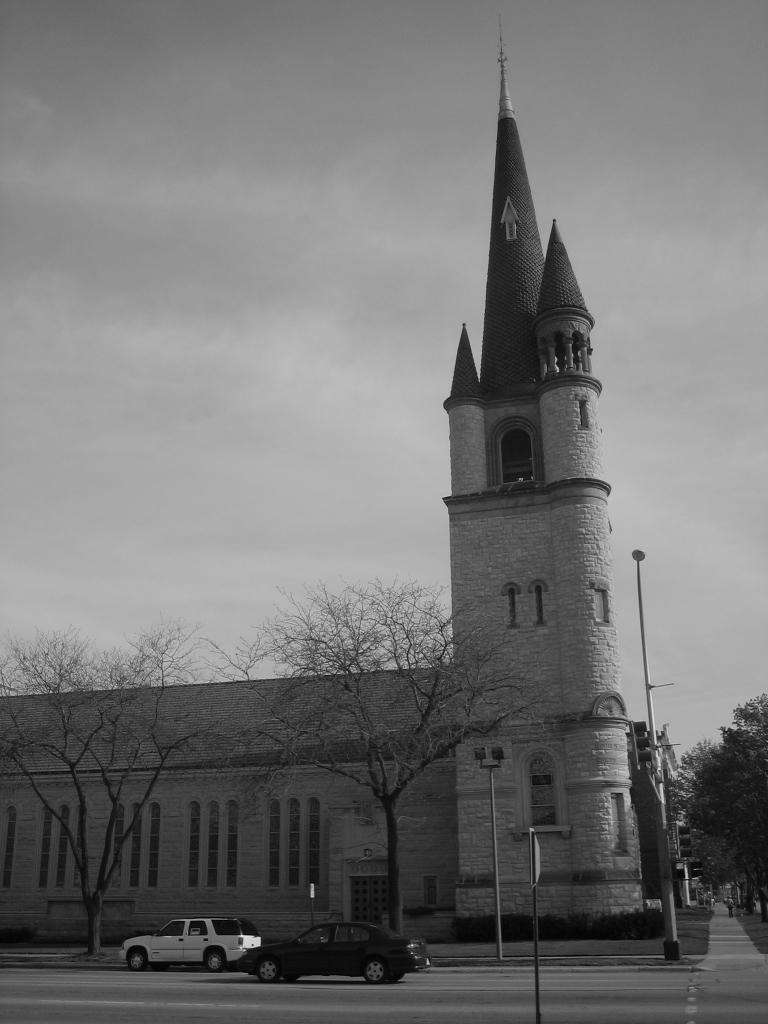Please provide a concise description of this image. In this image we can see a building, there are two vehicles on the road, some poles, trees, a signboard, and also we can see the sky. 